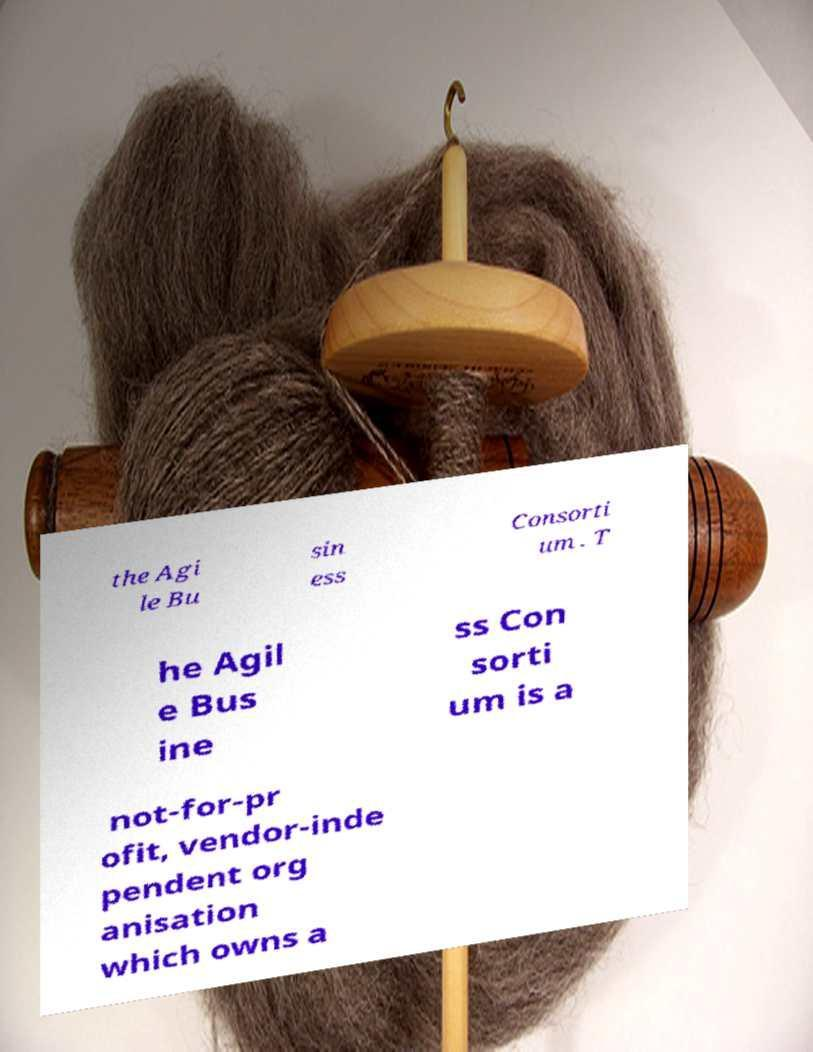Please identify and transcribe the text found in this image. the Agi le Bu sin ess Consorti um . T he Agil e Bus ine ss Con sorti um is a not-for-pr ofit, vendor-inde pendent org anisation which owns a 